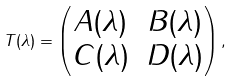<formula> <loc_0><loc_0><loc_500><loc_500>T ( \lambda ) = \begin{pmatrix} A ( \lambda ) & B ( \lambda ) \\ C ( \lambda ) & D ( \lambda ) \end{pmatrix} ,</formula> 